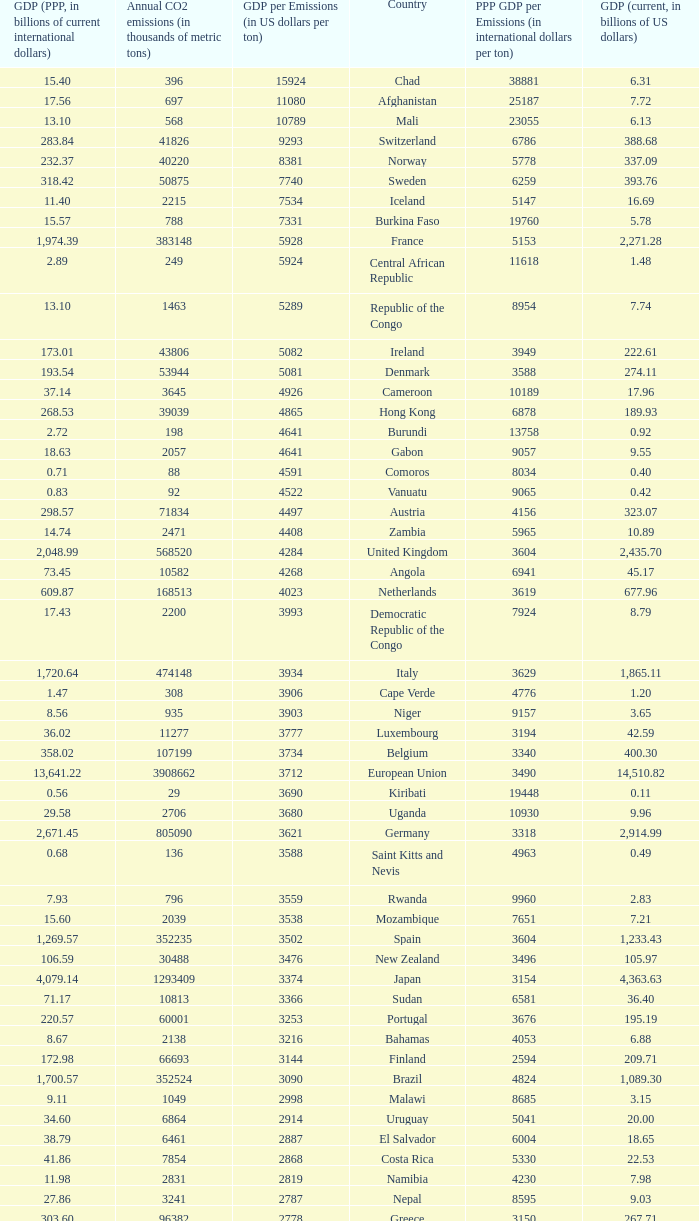50, what is the gdp? 2562.0. 